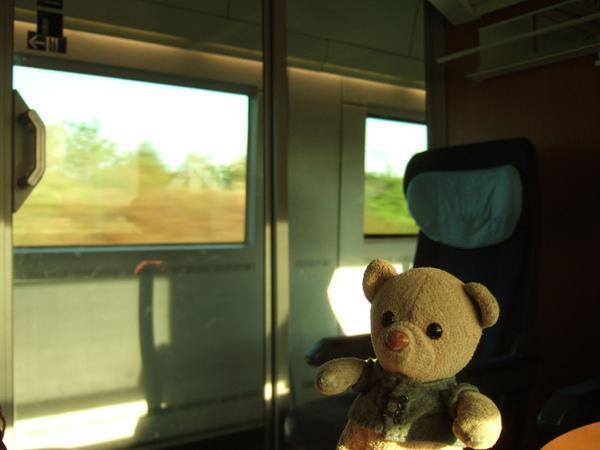How many windows is there?
Give a very brief answer. 2. How many people are wearing white hats in the picture?
Give a very brief answer. 0. 